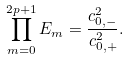Convert formula to latex. <formula><loc_0><loc_0><loc_500><loc_500>\prod _ { m = 0 } ^ { 2 p + 1 } E _ { m } = \frac { c _ { 0 , - } ^ { 2 } } { c _ { 0 , + } ^ { 2 } } .</formula> 